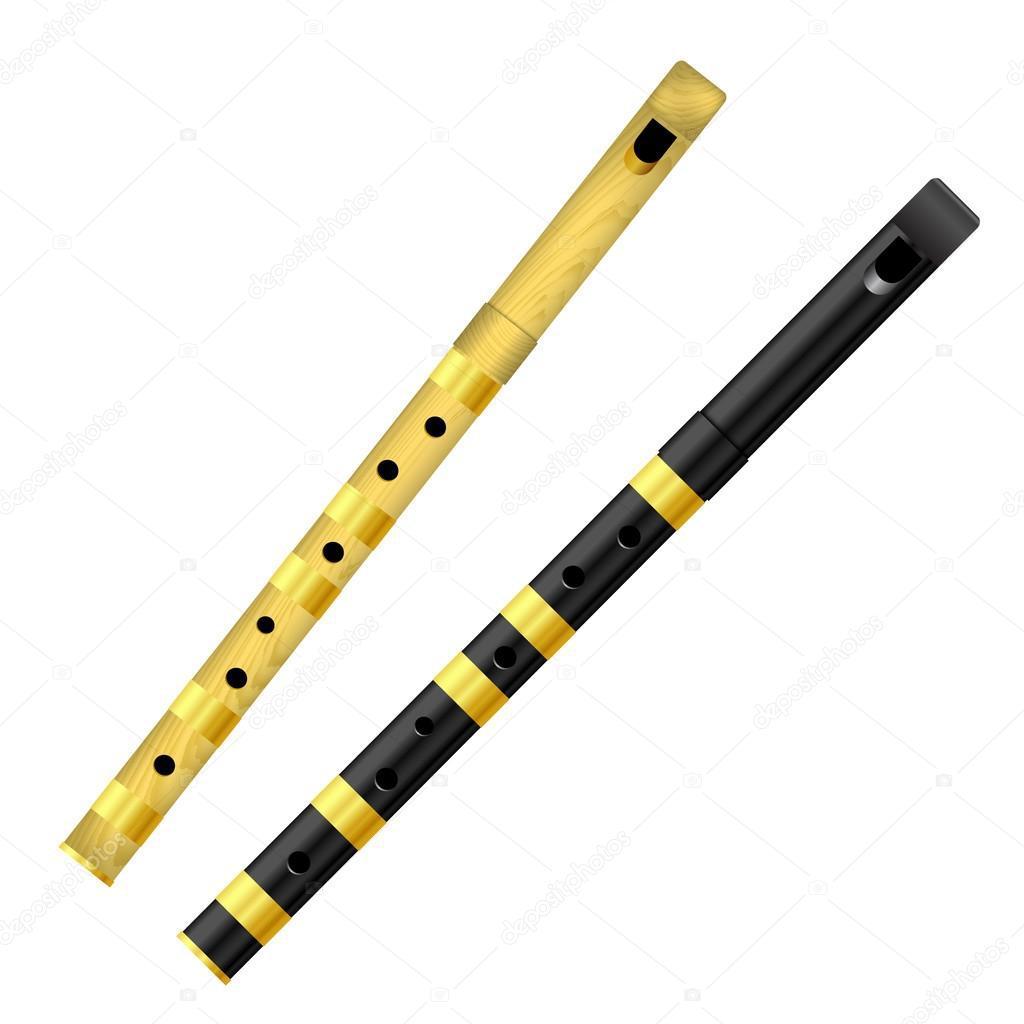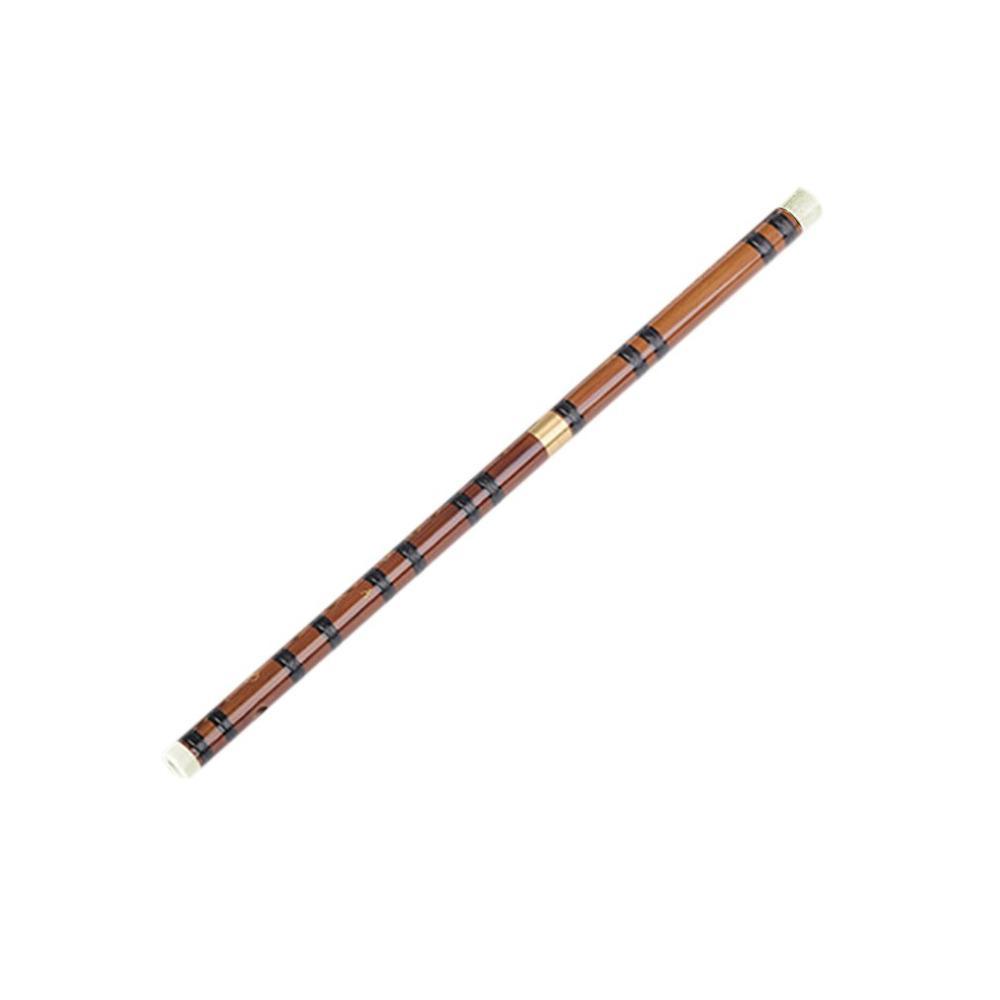The first image is the image on the left, the second image is the image on the right. Given the left and right images, does the statement "The left image contains a single flute displayed at an angle, and the right image contains at least one flute displayed at an angle opposite that of the flute on the left." hold true? Answer yes or no. No. The first image is the image on the left, the second image is the image on the right. For the images shown, is this caption "There are two flutes in the left image." true? Answer yes or no. Yes. 